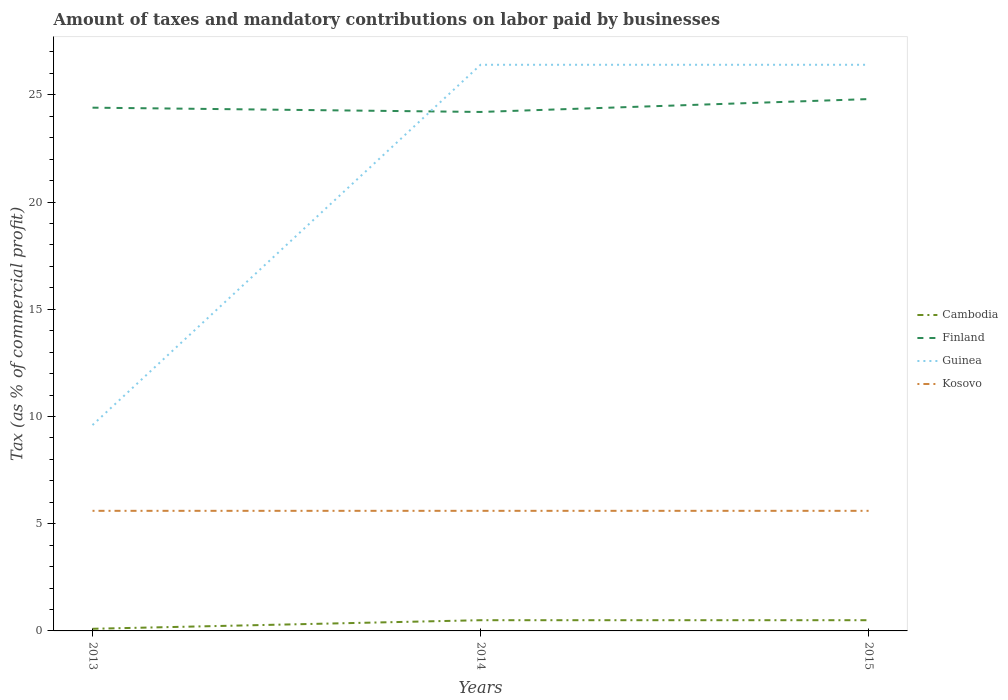How many different coloured lines are there?
Your answer should be very brief. 4. Does the line corresponding to Cambodia intersect with the line corresponding to Kosovo?
Make the answer very short. No. Is the number of lines equal to the number of legend labels?
Provide a succinct answer. Yes. What is the total percentage of taxes paid by businesses in Finland in the graph?
Your answer should be compact. -0.6. Is the percentage of taxes paid by businesses in Kosovo strictly greater than the percentage of taxes paid by businesses in Cambodia over the years?
Provide a short and direct response. No. How many years are there in the graph?
Keep it short and to the point. 3. What is the difference between two consecutive major ticks on the Y-axis?
Make the answer very short. 5. Does the graph contain any zero values?
Your answer should be compact. No. Where does the legend appear in the graph?
Provide a short and direct response. Center right. How many legend labels are there?
Offer a terse response. 4. What is the title of the graph?
Give a very brief answer. Amount of taxes and mandatory contributions on labor paid by businesses. Does "Albania" appear as one of the legend labels in the graph?
Offer a terse response. No. What is the label or title of the X-axis?
Keep it short and to the point. Years. What is the label or title of the Y-axis?
Provide a short and direct response. Tax (as % of commercial profit). What is the Tax (as % of commercial profit) of Cambodia in 2013?
Your answer should be compact. 0.1. What is the Tax (as % of commercial profit) in Finland in 2013?
Your answer should be compact. 24.4. What is the Tax (as % of commercial profit) of Guinea in 2013?
Offer a terse response. 9.6. What is the Tax (as % of commercial profit) in Kosovo in 2013?
Your answer should be very brief. 5.6. What is the Tax (as % of commercial profit) of Cambodia in 2014?
Your answer should be very brief. 0.5. What is the Tax (as % of commercial profit) of Finland in 2014?
Offer a very short reply. 24.2. What is the Tax (as % of commercial profit) in Guinea in 2014?
Give a very brief answer. 26.4. What is the Tax (as % of commercial profit) in Cambodia in 2015?
Offer a terse response. 0.5. What is the Tax (as % of commercial profit) of Finland in 2015?
Provide a short and direct response. 24.8. What is the Tax (as % of commercial profit) in Guinea in 2015?
Ensure brevity in your answer.  26.4. What is the Tax (as % of commercial profit) of Kosovo in 2015?
Your response must be concise. 5.6. Across all years, what is the maximum Tax (as % of commercial profit) in Finland?
Your answer should be very brief. 24.8. Across all years, what is the maximum Tax (as % of commercial profit) of Guinea?
Your answer should be very brief. 26.4. Across all years, what is the maximum Tax (as % of commercial profit) in Kosovo?
Keep it short and to the point. 5.6. Across all years, what is the minimum Tax (as % of commercial profit) of Finland?
Ensure brevity in your answer.  24.2. Across all years, what is the minimum Tax (as % of commercial profit) in Guinea?
Make the answer very short. 9.6. What is the total Tax (as % of commercial profit) of Finland in the graph?
Offer a very short reply. 73.4. What is the total Tax (as % of commercial profit) in Guinea in the graph?
Your response must be concise. 62.4. What is the difference between the Tax (as % of commercial profit) in Guinea in 2013 and that in 2014?
Provide a short and direct response. -16.8. What is the difference between the Tax (as % of commercial profit) of Kosovo in 2013 and that in 2014?
Give a very brief answer. 0. What is the difference between the Tax (as % of commercial profit) in Finland in 2013 and that in 2015?
Provide a short and direct response. -0.4. What is the difference between the Tax (as % of commercial profit) in Guinea in 2013 and that in 2015?
Provide a short and direct response. -16.8. What is the difference between the Tax (as % of commercial profit) of Finland in 2014 and that in 2015?
Offer a terse response. -0.6. What is the difference between the Tax (as % of commercial profit) in Cambodia in 2013 and the Tax (as % of commercial profit) in Finland in 2014?
Keep it short and to the point. -24.1. What is the difference between the Tax (as % of commercial profit) in Cambodia in 2013 and the Tax (as % of commercial profit) in Guinea in 2014?
Ensure brevity in your answer.  -26.3. What is the difference between the Tax (as % of commercial profit) in Finland in 2013 and the Tax (as % of commercial profit) in Kosovo in 2014?
Ensure brevity in your answer.  18.8. What is the difference between the Tax (as % of commercial profit) in Cambodia in 2013 and the Tax (as % of commercial profit) in Finland in 2015?
Ensure brevity in your answer.  -24.7. What is the difference between the Tax (as % of commercial profit) in Cambodia in 2013 and the Tax (as % of commercial profit) in Guinea in 2015?
Keep it short and to the point. -26.3. What is the difference between the Tax (as % of commercial profit) in Cambodia in 2013 and the Tax (as % of commercial profit) in Kosovo in 2015?
Provide a succinct answer. -5.5. What is the difference between the Tax (as % of commercial profit) of Finland in 2013 and the Tax (as % of commercial profit) of Guinea in 2015?
Provide a succinct answer. -2. What is the difference between the Tax (as % of commercial profit) in Guinea in 2013 and the Tax (as % of commercial profit) in Kosovo in 2015?
Your answer should be compact. 4. What is the difference between the Tax (as % of commercial profit) in Cambodia in 2014 and the Tax (as % of commercial profit) in Finland in 2015?
Keep it short and to the point. -24.3. What is the difference between the Tax (as % of commercial profit) in Cambodia in 2014 and the Tax (as % of commercial profit) in Guinea in 2015?
Give a very brief answer. -25.9. What is the difference between the Tax (as % of commercial profit) in Finland in 2014 and the Tax (as % of commercial profit) in Guinea in 2015?
Offer a very short reply. -2.2. What is the difference between the Tax (as % of commercial profit) in Finland in 2014 and the Tax (as % of commercial profit) in Kosovo in 2015?
Provide a succinct answer. 18.6. What is the difference between the Tax (as % of commercial profit) in Guinea in 2014 and the Tax (as % of commercial profit) in Kosovo in 2015?
Keep it short and to the point. 20.8. What is the average Tax (as % of commercial profit) of Cambodia per year?
Provide a succinct answer. 0.37. What is the average Tax (as % of commercial profit) of Finland per year?
Offer a terse response. 24.47. What is the average Tax (as % of commercial profit) of Guinea per year?
Make the answer very short. 20.8. In the year 2013, what is the difference between the Tax (as % of commercial profit) in Cambodia and Tax (as % of commercial profit) in Finland?
Provide a short and direct response. -24.3. In the year 2013, what is the difference between the Tax (as % of commercial profit) of Cambodia and Tax (as % of commercial profit) of Guinea?
Offer a terse response. -9.5. In the year 2013, what is the difference between the Tax (as % of commercial profit) in Cambodia and Tax (as % of commercial profit) in Kosovo?
Give a very brief answer. -5.5. In the year 2013, what is the difference between the Tax (as % of commercial profit) of Guinea and Tax (as % of commercial profit) of Kosovo?
Give a very brief answer. 4. In the year 2014, what is the difference between the Tax (as % of commercial profit) in Cambodia and Tax (as % of commercial profit) in Finland?
Ensure brevity in your answer.  -23.7. In the year 2014, what is the difference between the Tax (as % of commercial profit) in Cambodia and Tax (as % of commercial profit) in Guinea?
Offer a very short reply. -25.9. In the year 2014, what is the difference between the Tax (as % of commercial profit) in Cambodia and Tax (as % of commercial profit) in Kosovo?
Your response must be concise. -5.1. In the year 2014, what is the difference between the Tax (as % of commercial profit) of Finland and Tax (as % of commercial profit) of Guinea?
Offer a very short reply. -2.2. In the year 2014, what is the difference between the Tax (as % of commercial profit) of Guinea and Tax (as % of commercial profit) of Kosovo?
Offer a very short reply. 20.8. In the year 2015, what is the difference between the Tax (as % of commercial profit) of Cambodia and Tax (as % of commercial profit) of Finland?
Give a very brief answer. -24.3. In the year 2015, what is the difference between the Tax (as % of commercial profit) of Cambodia and Tax (as % of commercial profit) of Guinea?
Provide a succinct answer. -25.9. In the year 2015, what is the difference between the Tax (as % of commercial profit) of Finland and Tax (as % of commercial profit) of Guinea?
Give a very brief answer. -1.6. In the year 2015, what is the difference between the Tax (as % of commercial profit) of Finland and Tax (as % of commercial profit) of Kosovo?
Provide a succinct answer. 19.2. In the year 2015, what is the difference between the Tax (as % of commercial profit) of Guinea and Tax (as % of commercial profit) of Kosovo?
Keep it short and to the point. 20.8. What is the ratio of the Tax (as % of commercial profit) in Finland in 2013 to that in 2014?
Make the answer very short. 1.01. What is the ratio of the Tax (as % of commercial profit) in Guinea in 2013 to that in 2014?
Make the answer very short. 0.36. What is the ratio of the Tax (as % of commercial profit) of Cambodia in 2013 to that in 2015?
Provide a short and direct response. 0.2. What is the ratio of the Tax (as % of commercial profit) in Finland in 2013 to that in 2015?
Provide a succinct answer. 0.98. What is the ratio of the Tax (as % of commercial profit) of Guinea in 2013 to that in 2015?
Keep it short and to the point. 0.36. What is the ratio of the Tax (as % of commercial profit) of Finland in 2014 to that in 2015?
Give a very brief answer. 0.98. What is the ratio of the Tax (as % of commercial profit) of Guinea in 2014 to that in 2015?
Your answer should be compact. 1. What is the difference between the highest and the second highest Tax (as % of commercial profit) of Finland?
Provide a short and direct response. 0.4. What is the difference between the highest and the second highest Tax (as % of commercial profit) of Guinea?
Make the answer very short. 0. What is the difference between the highest and the second highest Tax (as % of commercial profit) in Kosovo?
Provide a short and direct response. 0. What is the difference between the highest and the lowest Tax (as % of commercial profit) of Cambodia?
Provide a succinct answer. 0.4. What is the difference between the highest and the lowest Tax (as % of commercial profit) in Finland?
Ensure brevity in your answer.  0.6. 